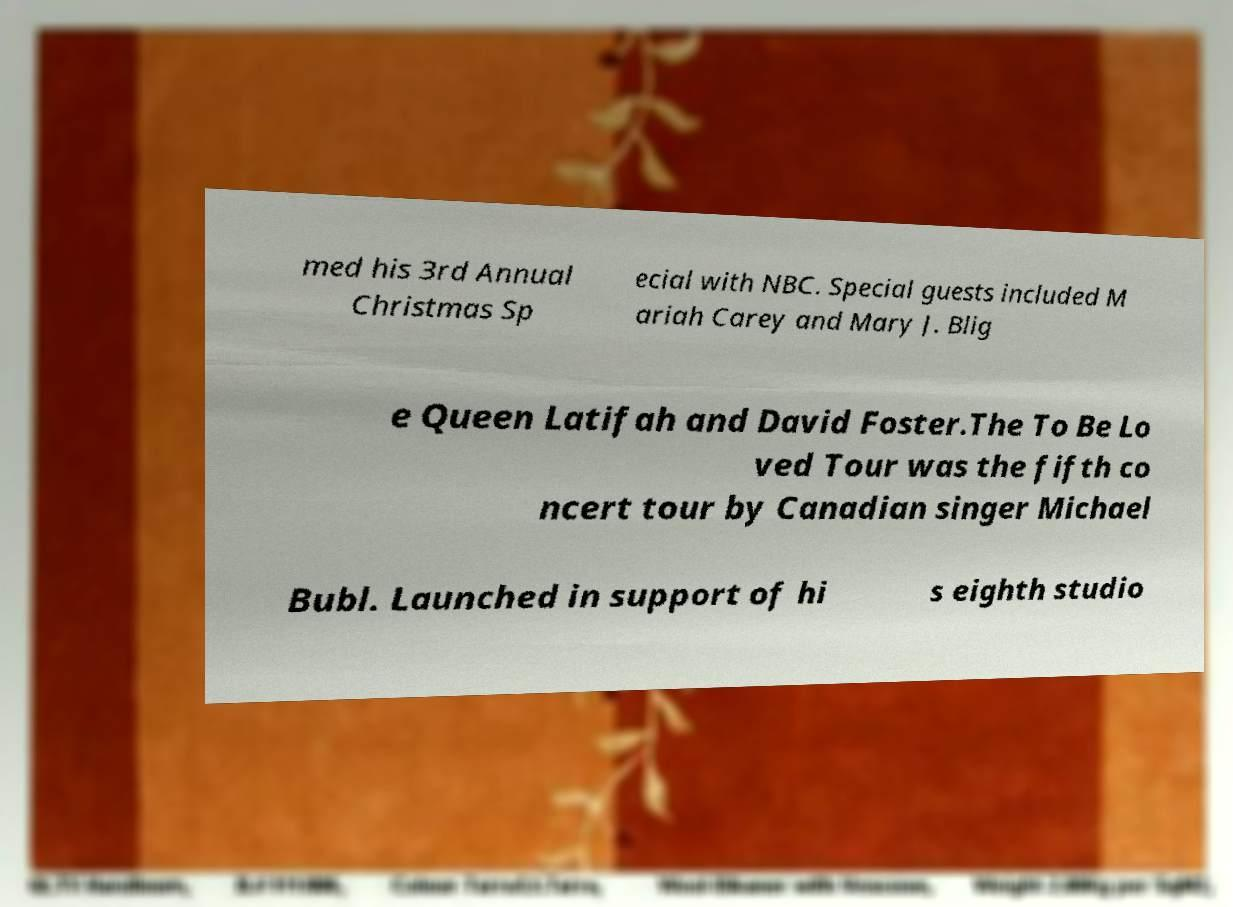What messages or text are displayed in this image? I need them in a readable, typed format. med his 3rd Annual Christmas Sp ecial with NBC. Special guests included M ariah Carey and Mary J. Blig e Queen Latifah and David Foster.The To Be Lo ved Tour was the fifth co ncert tour by Canadian singer Michael Bubl. Launched in support of hi s eighth studio 